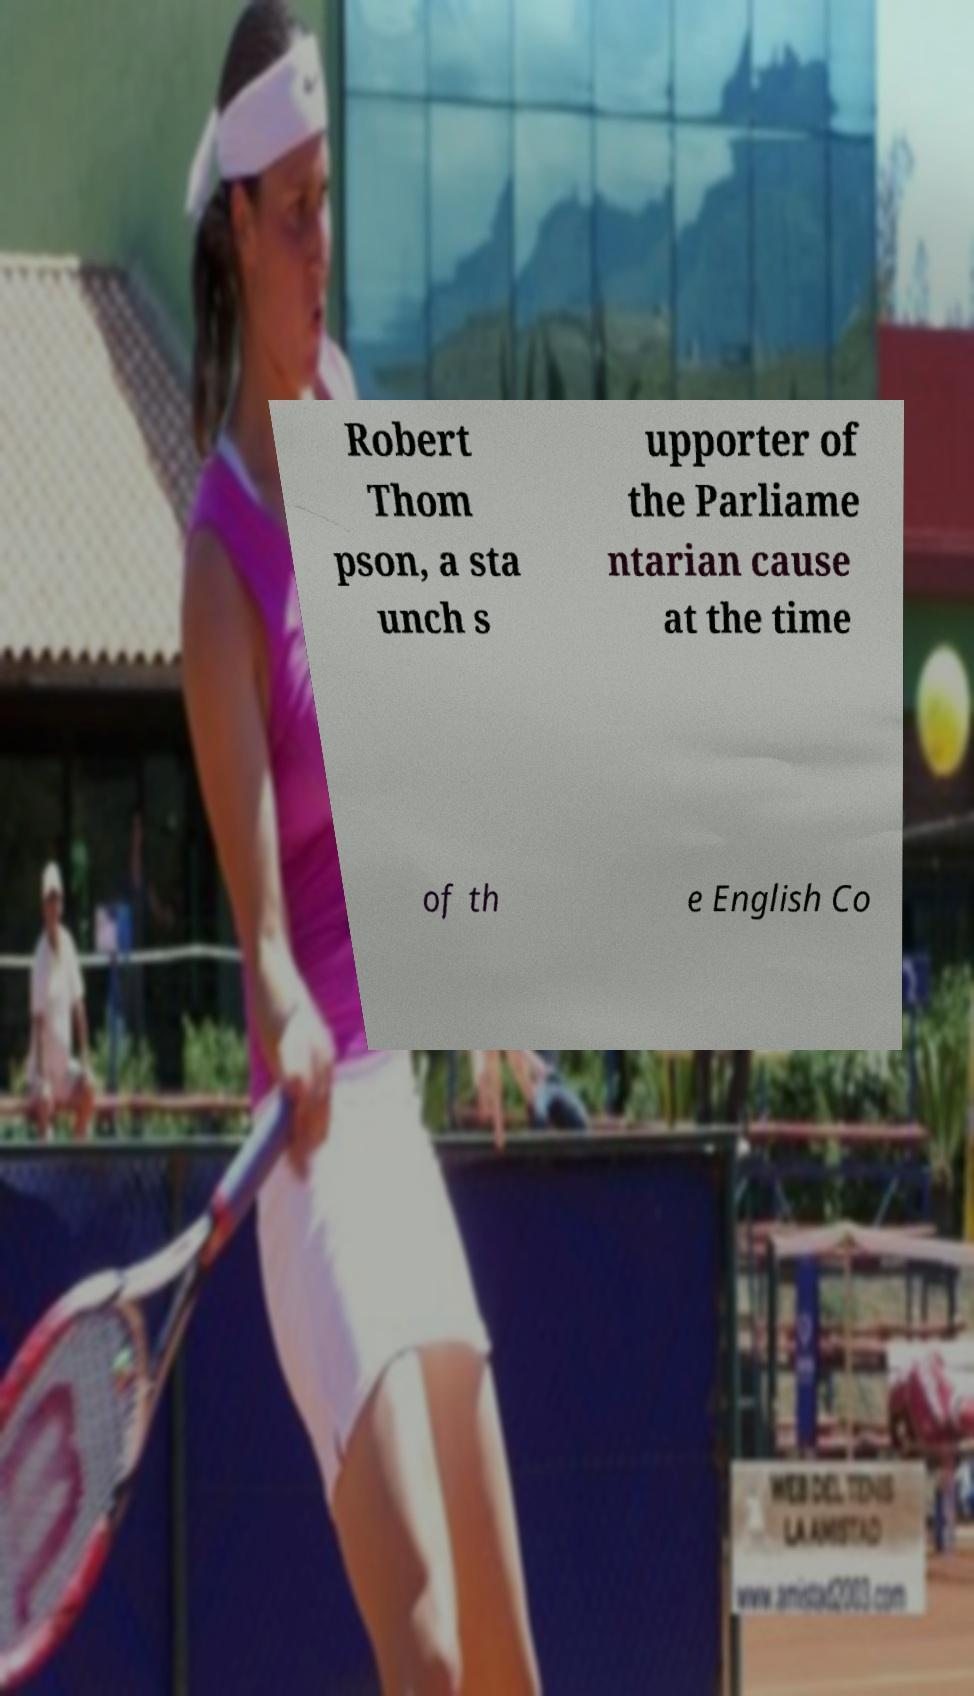Could you extract and type out the text from this image? Robert Thom pson, a sta unch s upporter of the Parliame ntarian cause at the time of th e English Co 